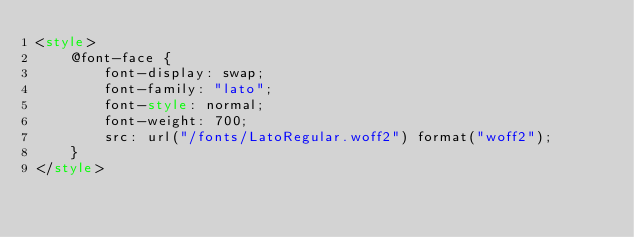<code> <loc_0><loc_0><loc_500><loc_500><_HTML_><style>
    @font-face {
        font-display: swap;
        font-family: "lato";
        font-style: normal;
        font-weight: 700;
        src: url("/fonts/LatoRegular.woff2") format("woff2");
    }
</style></code> 